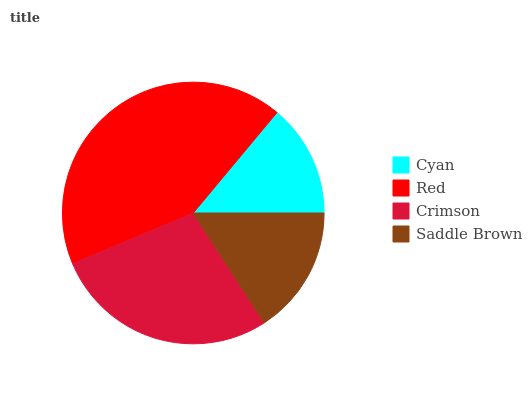Is Cyan the minimum?
Answer yes or no. Yes. Is Red the maximum?
Answer yes or no. Yes. Is Crimson the minimum?
Answer yes or no. No. Is Crimson the maximum?
Answer yes or no. No. Is Red greater than Crimson?
Answer yes or no. Yes. Is Crimson less than Red?
Answer yes or no. Yes. Is Crimson greater than Red?
Answer yes or no. No. Is Red less than Crimson?
Answer yes or no. No. Is Crimson the high median?
Answer yes or no. Yes. Is Saddle Brown the low median?
Answer yes or no. Yes. Is Saddle Brown the high median?
Answer yes or no. No. Is Red the low median?
Answer yes or no. No. 